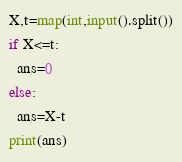Convert code to text. <code><loc_0><loc_0><loc_500><loc_500><_Python_>X,t=map(int,input().split())
if X<=t:
  ans=0
else:
  ans=X-t
print(ans)</code> 